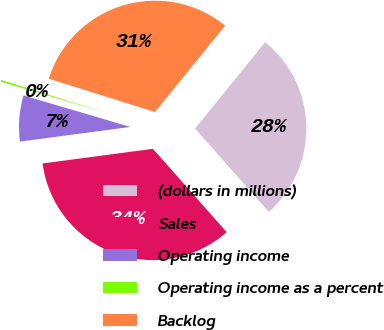<chart> <loc_0><loc_0><loc_500><loc_500><pie_chart><fcel>(dollars in millions)<fcel>Sales<fcel>Operating income<fcel>Operating income as a percent<fcel>Backlog<nl><fcel>27.61%<fcel>34.43%<fcel>6.67%<fcel>0.27%<fcel>31.02%<nl></chart> 